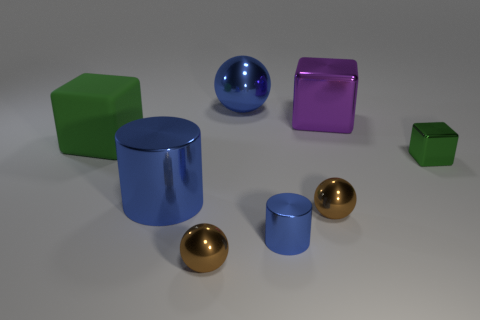Add 1 blocks. How many objects exist? 9 Subtract all big blocks. How many blocks are left? 1 Subtract all brown cubes. How many brown spheres are left? 2 Subtract 1 spheres. How many spheres are left? 2 Subtract all spheres. How many objects are left? 5 Add 1 green rubber objects. How many green rubber objects are left? 2 Add 5 small yellow metallic things. How many small yellow metallic things exist? 5 Subtract 0 red cylinders. How many objects are left? 8 Subtract all cyan balls. Subtract all red cubes. How many balls are left? 3 Subtract all large spheres. Subtract all brown shiny things. How many objects are left? 5 